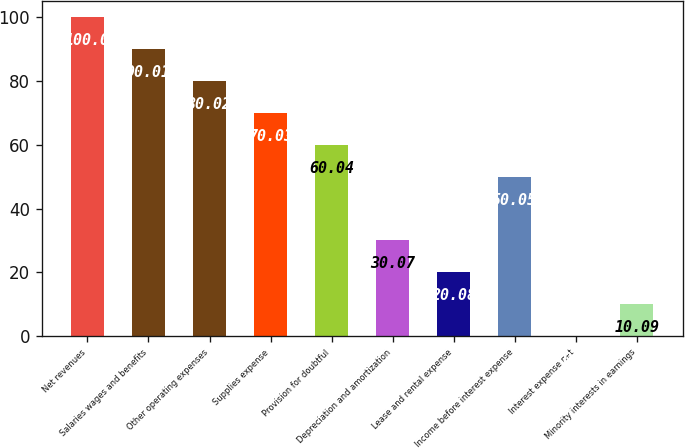Convert chart to OTSL. <chart><loc_0><loc_0><loc_500><loc_500><bar_chart><fcel>Net revenues<fcel>Salaries wages and benefits<fcel>Other operating expenses<fcel>Supplies expense<fcel>Provision for doubtful<fcel>Depreciation and amortization<fcel>Lease and rental expense<fcel>Income before interest expense<fcel>Interest expense net<fcel>Minority interests in earnings<nl><fcel>100<fcel>90.01<fcel>80.02<fcel>70.03<fcel>60.04<fcel>30.07<fcel>20.08<fcel>50.05<fcel>0.1<fcel>10.09<nl></chart> 